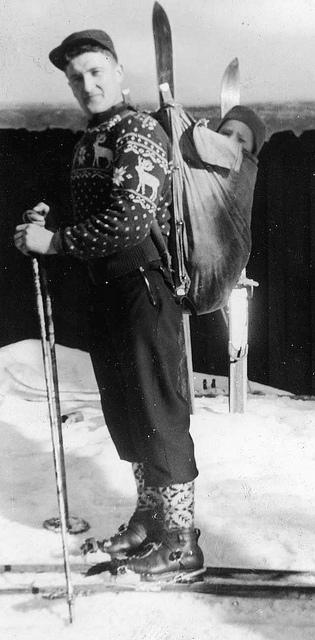Is this person a professional water surfer?
Concise answer only. No. Is this safe?
Concise answer only. No. Is this a new photo?
Concise answer only. No. Where is the child?
Concise answer only. Backpack. 